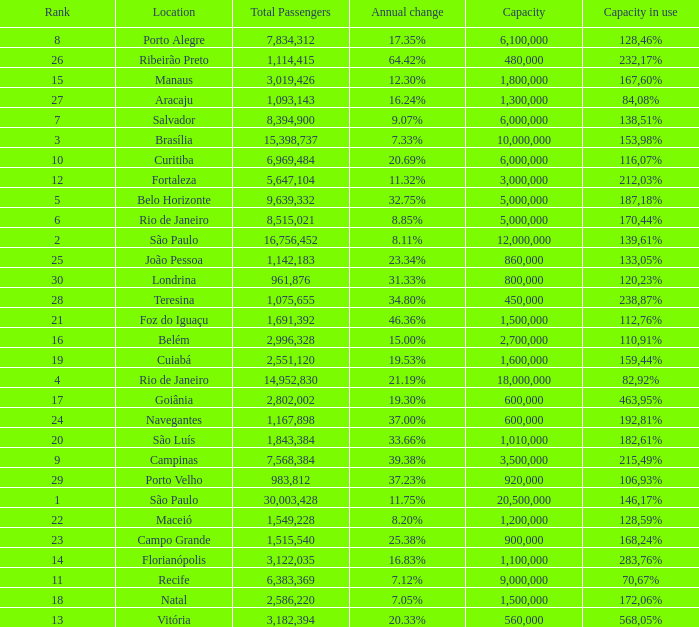Write the full table. {'header': ['Rank', 'Location', 'Total Passengers', 'Annual change', 'Capacity', 'Capacity in use'], 'rows': [['8', 'Porto Alegre', '7,834,312', '17.35%', '6,100,000', '128,46%'], ['26', 'Ribeirão Preto', '1,114,415', '64.42%', '480,000', '232,17%'], ['15', 'Manaus', '3,019,426', '12.30%', '1,800,000', '167,60%'], ['27', 'Aracaju', '1,093,143', '16.24%', '1,300,000', '84,08%'], ['7', 'Salvador', '8,394,900', '9.07%', '6,000,000', '138,51%'], ['3', 'Brasília', '15,398,737', '7.33%', '10,000,000', '153,98%'], ['10', 'Curitiba', '6,969,484', '20.69%', '6,000,000', '116,07%'], ['12', 'Fortaleza', '5,647,104', '11.32%', '3,000,000', '212,03%'], ['5', 'Belo Horizonte', '9,639,332', '32.75%', '5,000,000', '187,18%'], ['6', 'Rio de Janeiro', '8,515,021', '8.85%', '5,000,000', '170,44%'], ['2', 'São Paulo', '16,756,452', '8.11%', '12,000,000', '139,61%'], ['25', 'João Pessoa', '1,142,183', '23.34%', '860,000', '133,05%'], ['30', 'Londrina', '961,876', '31.33%', '800,000', '120,23%'], ['28', 'Teresina', '1,075,655', '34.80%', '450,000', '238,87%'], ['21', 'Foz do Iguaçu', '1,691,392', '46.36%', '1,500,000', '112,76%'], ['16', 'Belém', '2,996,328', '15.00%', '2,700,000', '110,91%'], ['19', 'Cuiabá', '2,551,120', '19.53%', '1,600,000', '159,44%'], ['4', 'Rio de Janeiro', '14,952,830', '21.19%', '18,000,000', '82,92%'], ['17', 'Goiânia', '2,802,002', '19.30%', '600,000', '463,95%'], ['24', 'Navegantes', '1,167,898', '37.00%', '600,000', '192,81%'], ['20', 'São Luís', '1,843,384', '33.66%', '1,010,000', '182,61%'], ['9', 'Campinas', '7,568,384', '39.38%', '3,500,000', '215,49%'], ['29', 'Porto Velho', '983,812', '37.23%', '920,000', '106,93%'], ['1', 'São Paulo', '30,003,428', '11.75%', '20,500,000', '146,17%'], ['22', 'Maceió', '1,549,228', '8.20%', '1,200,000', '128,59%'], ['23', 'Campo Grande', '1,515,540', '25.38%', '900,000', '168,24%'], ['14', 'Florianópolis', '3,122,035', '16.83%', '1,100,000', '283,76%'], ['11', 'Recife', '6,383,369', '7.12%', '9,000,000', '70,67%'], ['18', 'Natal', '2,586,220', '7.05%', '1,500,000', '172,06%'], ['13', 'Vitória', '3,182,394', '20.33%', '560,000', '568,05%']]} Which location has a capacity that has a rank of 23? 168,24%. 